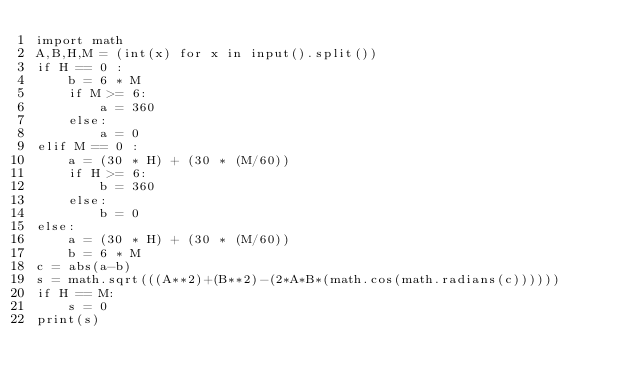<code> <loc_0><loc_0><loc_500><loc_500><_Python_>import math
A,B,H,M = (int(x) for x in input().split())
if H == 0 :
    b = 6 * M
    if M >= 6:
        a = 360
    else:
        a = 0
elif M == 0 :
    a = (30 * H) + (30 * (M/60))
    if H >= 6:
        b = 360
    else:
        b = 0
else:
    a = (30 * H) + (30 * (M/60))
    b = 6 * M
c = abs(a-b)
s = math.sqrt(((A**2)+(B**2)-(2*A*B*(math.cos(math.radians(c))))))
if H == M:
    s = 0
print(s)
</code> 